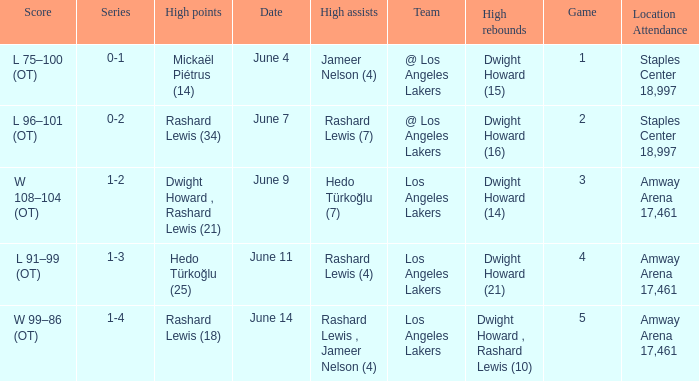What is High Points, when High Rebounds is "Dwight Howard (16)"? Rashard Lewis (34). 